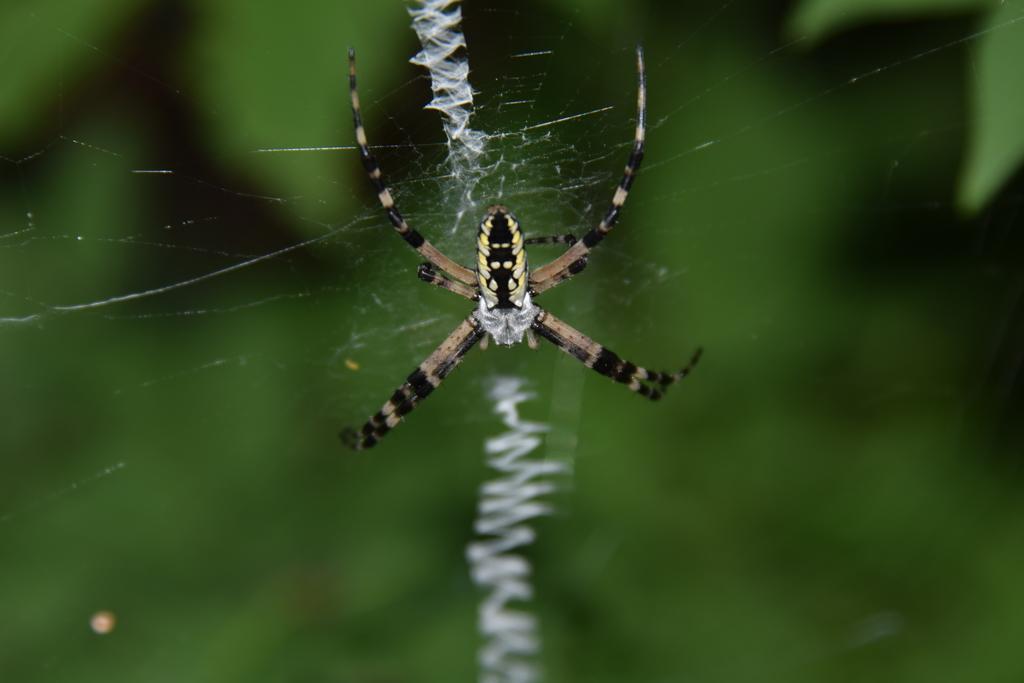Describe this image in one or two sentences. In this picture I can see spider in the spider web and I can see blurry black background. 